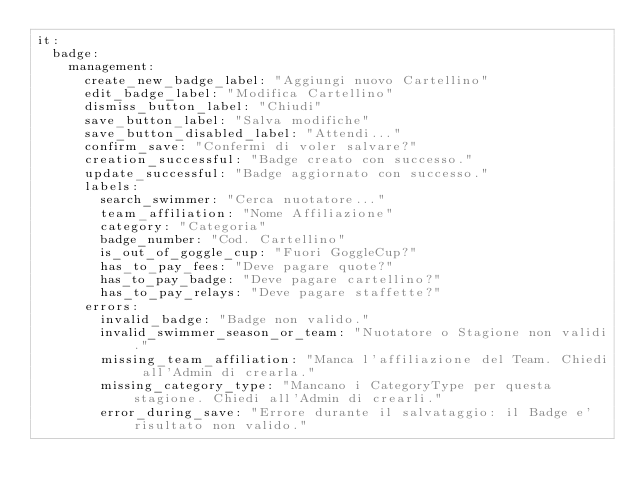<code> <loc_0><loc_0><loc_500><loc_500><_YAML_>it:
  badge:
    management:
      create_new_badge_label: "Aggiungi nuovo Cartellino"
      edit_badge_label: "Modifica Cartellino"
      dismiss_button_label: "Chiudi"
      save_button_label: "Salva modifiche"
      save_button_disabled_label: "Attendi..."
      confirm_save: "Confermi di voler salvare?"
      creation_successful: "Badge creato con successo."
      update_successful: "Badge aggiornato con successo."
      labels:
        search_swimmer: "Cerca nuotatore..."
        team_affiliation: "Nome Affiliazione"
        category: "Categoria"
        badge_number: "Cod. Cartellino"
        is_out_of_goggle_cup: "Fuori GoggleCup?"
        has_to_pay_fees: "Deve pagare quote?"
        has_to_pay_badge: "Deve pagare cartellino?"
        has_to_pay_relays: "Deve pagare staffette?"
      errors:
        invalid_badge: "Badge non valido."
        invalid_swimmer_season_or_team: "Nuotatore o Stagione non validi."
        missing_team_affiliation: "Manca l'affiliazione del Team. Chiedi all'Admin di crearla."
        missing_category_type: "Mancano i CategoryType per questa stagione. Chiedi all'Admin di crearli."
        error_during_save: "Errore durante il salvataggio: il Badge e' risultato non valido."
</code> 